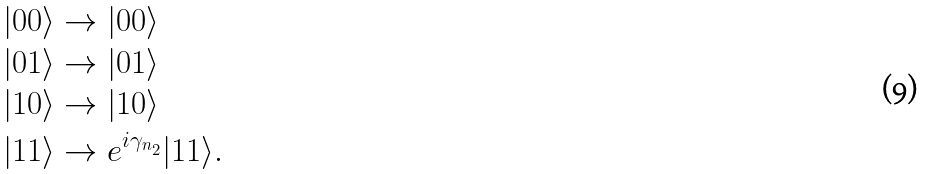Convert formula to latex. <formula><loc_0><loc_0><loc_500><loc_500>| 0 0 \rangle & \rightarrow | 0 0 \rangle \\ | 0 1 \rangle & \rightarrow | 0 1 \rangle \\ | 1 0 \rangle & \rightarrow | 1 0 \rangle \\ | 1 1 \rangle & \rightarrow e ^ { i \gamma _ { n _ { 2 } } } | 1 1 \rangle . \\</formula> 